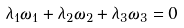Convert formula to latex. <formula><loc_0><loc_0><loc_500><loc_500>\lambda _ { 1 } \omega _ { 1 } + \lambda _ { 2 } \omega _ { 2 } + \lambda _ { 3 } \omega _ { 3 } = 0</formula> 